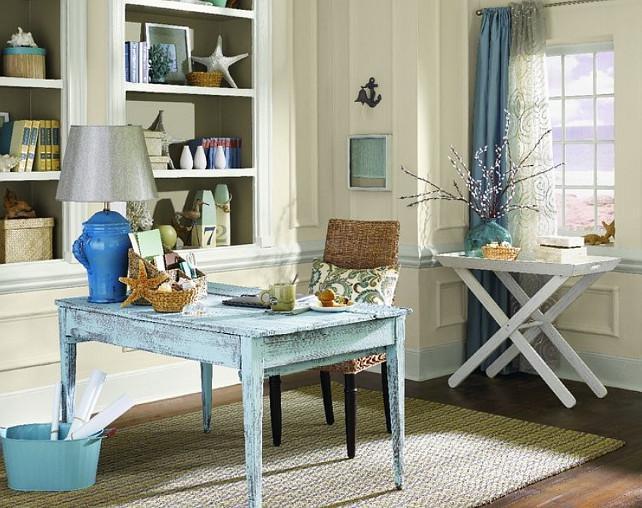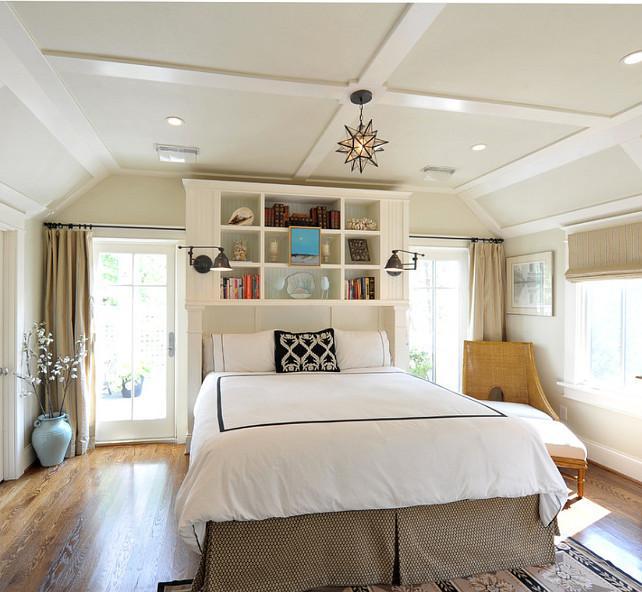The first image is the image on the left, the second image is the image on the right. For the images shown, is this caption "there is a chair in the image on the left" true? Answer yes or no. Yes. The first image is the image on the left, the second image is the image on the right. Analyze the images presented: Is the assertion "In at least one image, a shelving unit is used as a room divider." valid? Answer yes or no. No. 